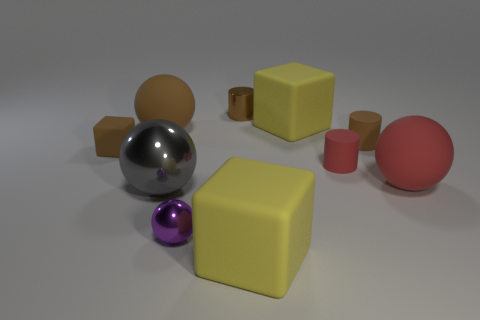The sphere that is the same color as the metallic cylinder is what size?
Offer a very short reply. Large. How many tiny rubber cylinders are in front of the tiny brown rubber thing on the left side of the tiny cylinder to the right of the small red matte object?
Offer a terse response. 1. There is a tiny rubber block; is it the same color as the matte cylinder left of the brown matte cylinder?
Make the answer very short. No. What shape is the shiny thing that is the same color as the small block?
Ensure brevity in your answer.  Cylinder. What material is the large yellow thing that is in front of the red rubber object to the right of the tiny brown matte object that is to the right of the brown metallic object made of?
Offer a terse response. Rubber. There is a large yellow matte object behind the red sphere; does it have the same shape as the big gray metallic object?
Give a very brief answer. No. There is a large yellow cube in front of the purple metal ball; what material is it?
Provide a short and direct response. Rubber. How many large red rubber things have the same shape as the tiny purple shiny object?
Provide a succinct answer. 1. What is the material of the large yellow thing behind the brown matte thing to the right of the brown sphere?
Provide a short and direct response. Rubber. What size is the brown object that is on the right side of the small brown metallic object?
Offer a terse response. Small. 